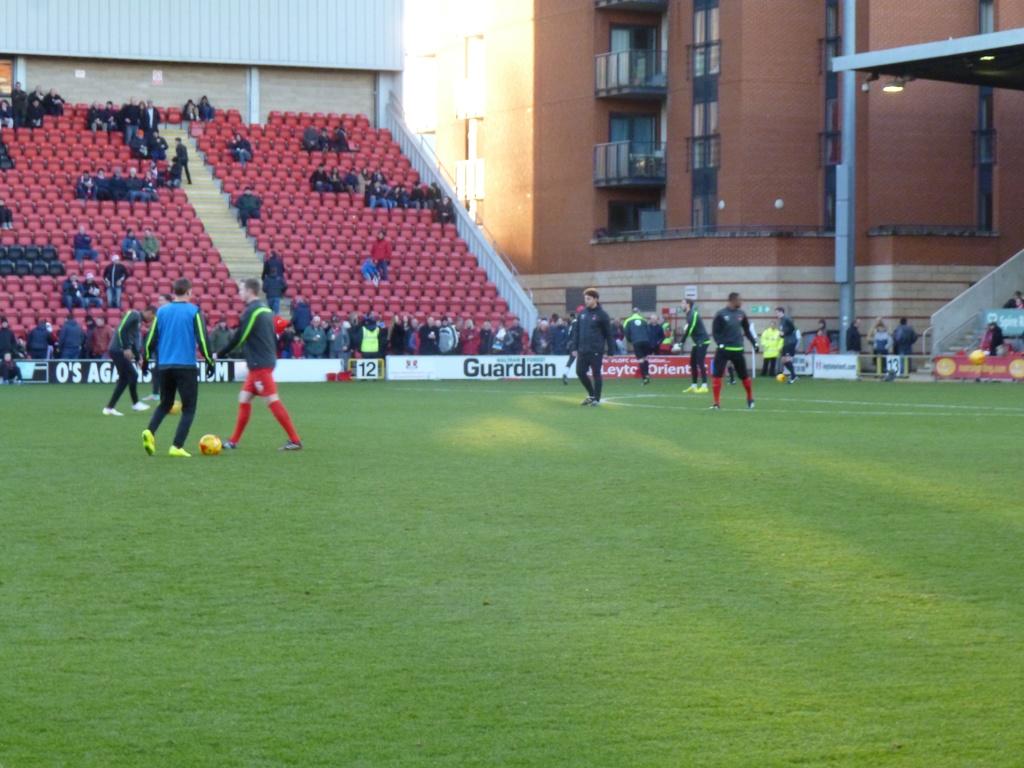Who is an advertiser?
Make the answer very short. Guardian. 